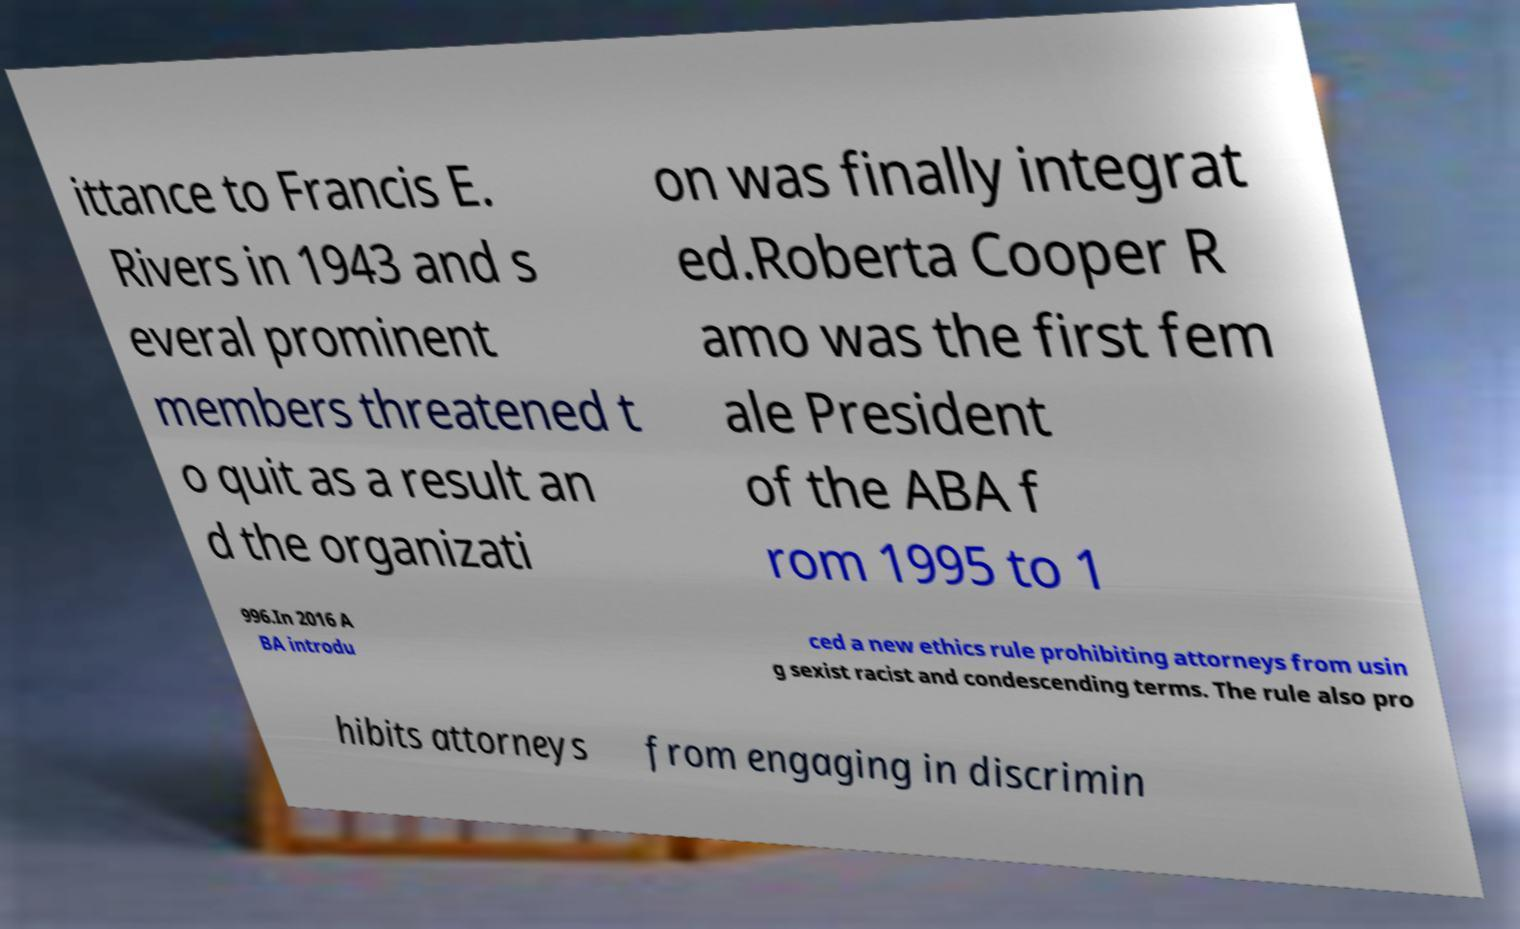For documentation purposes, I need the text within this image transcribed. Could you provide that? ittance to Francis E. Rivers in 1943 and s everal prominent members threatened t o quit as a result an d the organizati on was finally integrat ed.Roberta Cooper R amo was the first fem ale President of the ABA f rom 1995 to 1 996.In 2016 A BA introdu ced a new ethics rule prohibiting attorneys from usin g sexist racist and condescending terms. The rule also pro hibits attorneys from engaging in discrimin 